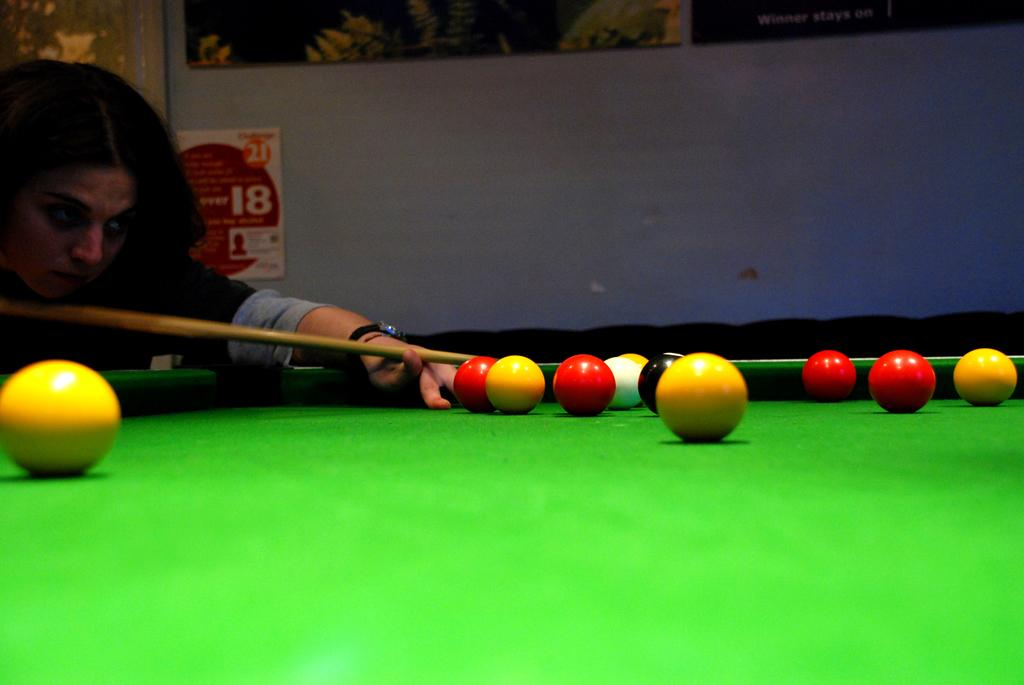Who is the main subject in the image? There is a woman in the image. What is the woman holding in the image? The woman is holding a stick in the image. What activity is the woman engaged in? The woman is playing billiards in the image. What is the woman doing with the balls on the table? The woman is hitting balls on a table in the image. What can be seen in the background of the image? There is a wall in the background of the image, and wall frames are hanging on the wall. What type of soap is the woman using to clean the balls in the image? There is no soap present in the image, and the woman is not cleaning the balls; she is playing billiards. 